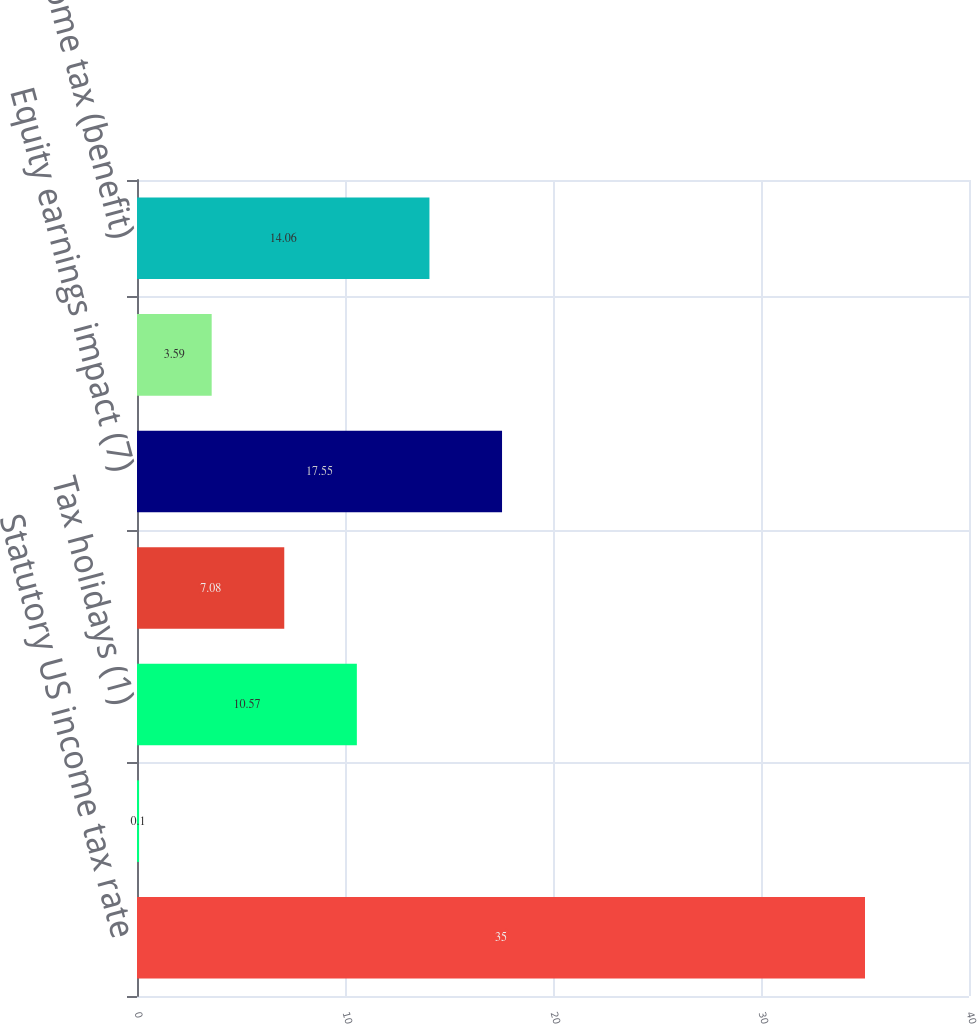<chart> <loc_0><loc_0><loc_500><loc_500><bar_chart><fcel>Statutory US income tax rate<fcel>State income tax (benefit) net<fcel>Tax holidays (1)<fcel>Rate difference on foreign<fcel>Equity earnings impact (7)<fcel>Tax (expenses) benefits not<fcel>Effective income tax (benefit)<nl><fcel>35<fcel>0.1<fcel>10.57<fcel>7.08<fcel>17.55<fcel>3.59<fcel>14.06<nl></chart> 